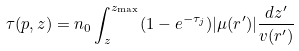<formula> <loc_0><loc_0><loc_500><loc_500>\tau ( p , z ) = n _ { 0 } \int ^ { z _ { \max } } _ { z } ( 1 - e ^ { - \tau _ { j } } ) | \mu ( r ^ { \prime } ) | \frac { d z ^ { \prime } } { v ( r ^ { \prime } ) }</formula> 